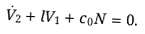Convert formula to latex. <formula><loc_0><loc_0><loc_500><loc_500>\dot { V } _ { 2 } + l V _ { 1 } + c _ { 0 } N = 0 .</formula> 